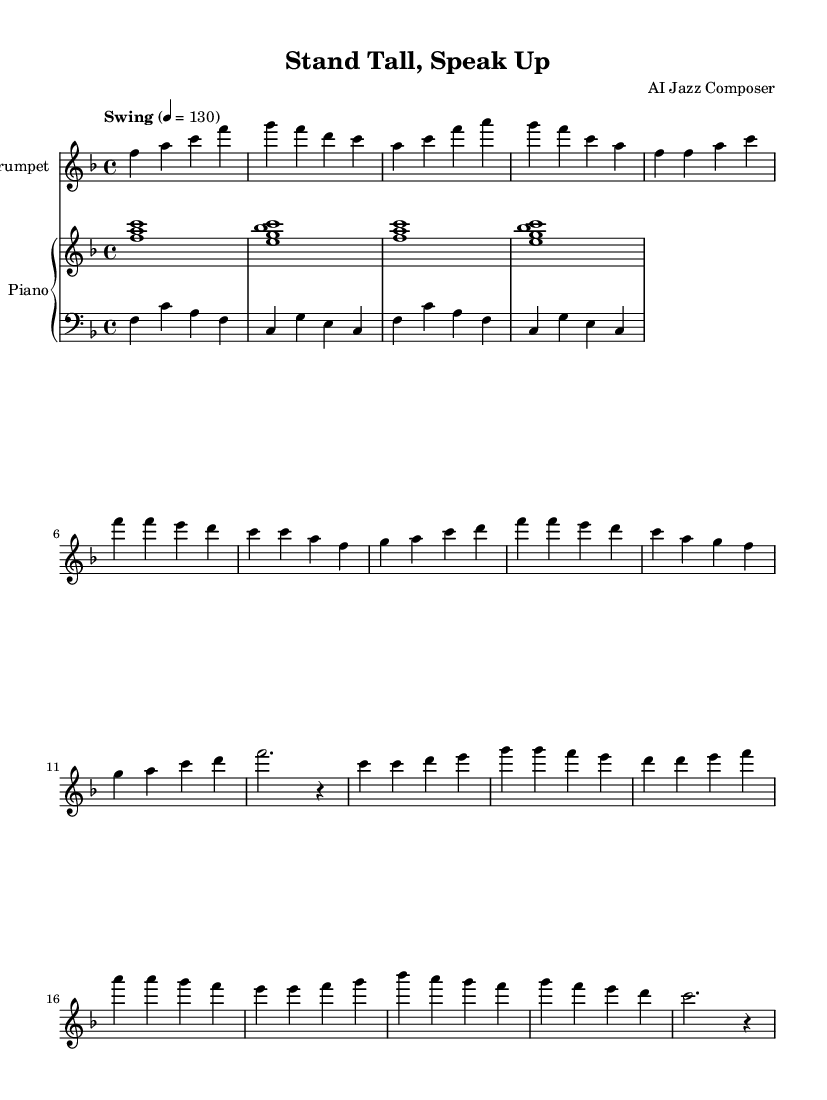What is the key signature of this music? The key signature shown at the beginning of the sheet music indicates F major, which has one flat. You can identify this by looking at the key signature symbol, which is positioned after the clef sign.
Answer: F major What is the time signature of the piece? The time signature is indicated at the beginning of the score, where you see "4/4". This means there are four beats in each measure and the quarter note gets one beat.
Answer: 4/4 What is the tempo marking for this piece? The tempo marking is found in the header section, where it states "Swing" with a tempo of "4 = 130". This means the piece should be played in a swinging style at a speed of 130 beats per minute.
Answer: Swing, 130 How many measures are there in the A section? To find this, you can count the measures labeled as the A section in the sheet music. The A section written above consists of four measures and is an abbreviated version of the full A section.
Answer: 4 Which instrument is featured in this score? The score prominently displays "Trumpet" at the top of the staff, indicating that this instrument is the main focus of the piece. The notation is explicitly stated in the instrument header above the staff.
Answer: Trumpet What is the pattern of the chords in the intro for the piano? The introduction consists of a repeated chord pattern using F, A, C, E, G, and B flat notes. By looking at the chords written in the piano staff section, you can observe the sequence and their voicings.
Answer: F, A, C, E, G, B flat What jazz element is emphasized in this piece? The piece prominently features a swing feel, which is a fundamental characteristic of jazz music. You can determine this by the tempo marking and the style indicated in the score, specifically stating "Swing".
Answer: Swing feel 